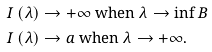Convert formula to latex. <formula><loc_0><loc_0><loc_500><loc_500>I \left ( \lambda \right ) & \rightarrow + \infty \text { when } \lambda \rightarrow \inf B \\ I \left ( \lambda \right ) & \rightarrow a \text { when } \lambda \rightarrow + \infty .</formula> 